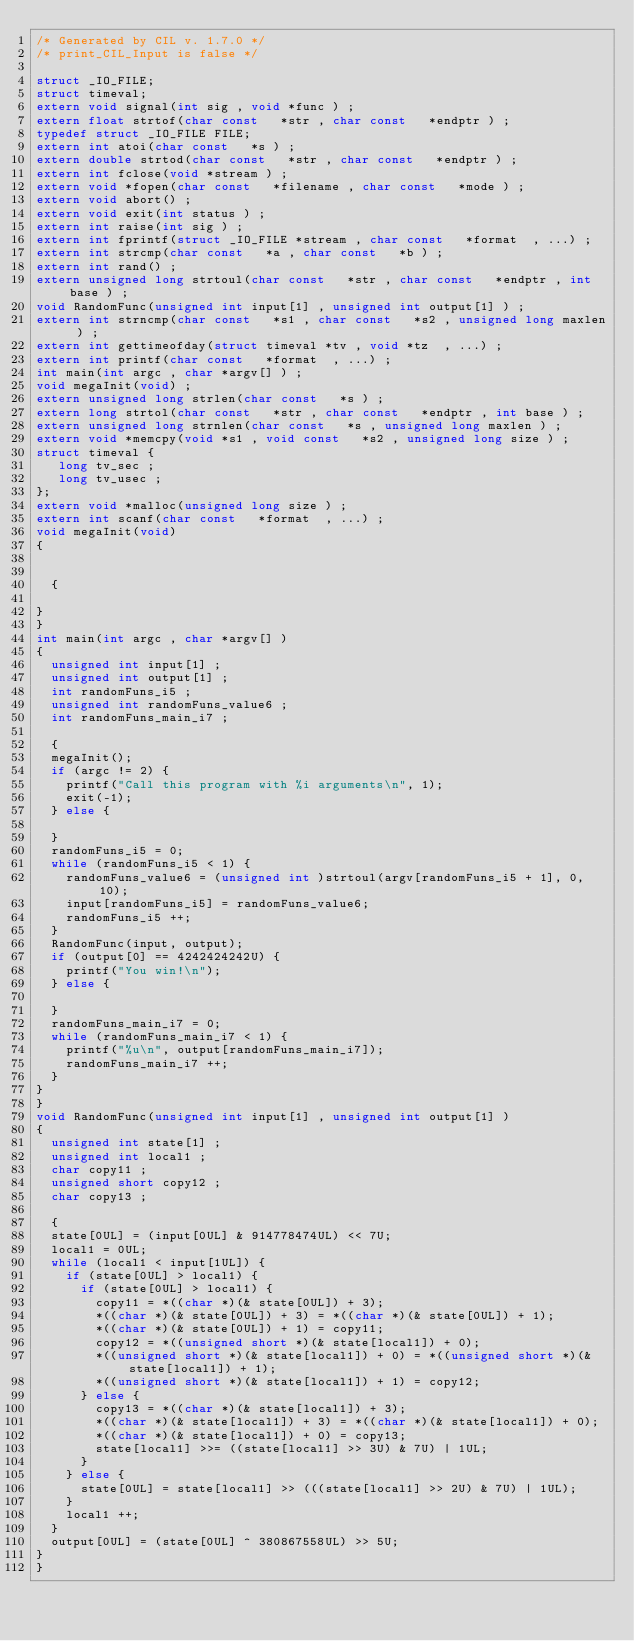<code> <loc_0><loc_0><loc_500><loc_500><_C_>/* Generated by CIL v. 1.7.0 */
/* print_CIL_Input is false */

struct _IO_FILE;
struct timeval;
extern void signal(int sig , void *func ) ;
extern float strtof(char const   *str , char const   *endptr ) ;
typedef struct _IO_FILE FILE;
extern int atoi(char const   *s ) ;
extern double strtod(char const   *str , char const   *endptr ) ;
extern int fclose(void *stream ) ;
extern void *fopen(char const   *filename , char const   *mode ) ;
extern void abort() ;
extern void exit(int status ) ;
extern int raise(int sig ) ;
extern int fprintf(struct _IO_FILE *stream , char const   *format  , ...) ;
extern int strcmp(char const   *a , char const   *b ) ;
extern int rand() ;
extern unsigned long strtoul(char const   *str , char const   *endptr , int base ) ;
void RandomFunc(unsigned int input[1] , unsigned int output[1] ) ;
extern int strncmp(char const   *s1 , char const   *s2 , unsigned long maxlen ) ;
extern int gettimeofday(struct timeval *tv , void *tz  , ...) ;
extern int printf(char const   *format  , ...) ;
int main(int argc , char *argv[] ) ;
void megaInit(void) ;
extern unsigned long strlen(char const   *s ) ;
extern long strtol(char const   *str , char const   *endptr , int base ) ;
extern unsigned long strnlen(char const   *s , unsigned long maxlen ) ;
extern void *memcpy(void *s1 , void const   *s2 , unsigned long size ) ;
struct timeval {
   long tv_sec ;
   long tv_usec ;
};
extern void *malloc(unsigned long size ) ;
extern int scanf(char const   *format  , ...) ;
void megaInit(void) 
{ 


  {

}
}
int main(int argc , char *argv[] ) 
{ 
  unsigned int input[1] ;
  unsigned int output[1] ;
  int randomFuns_i5 ;
  unsigned int randomFuns_value6 ;
  int randomFuns_main_i7 ;

  {
  megaInit();
  if (argc != 2) {
    printf("Call this program with %i arguments\n", 1);
    exit(-1);
  } else {

  }
  randomFuns_i5 = 0;
  while (randomFuns_i5 < 1) {
    randomFuns_value6 = (unsigned int )strtoul(argv[randomFuns_i5 + 1], 0, 10);
    input[randomFuns_i5] = randomFuns_value6;
    randomFuns_i5 ++;
  }
  RandomFunc(input, output);
  if (output[0] == 4242424242U) {
    printf("You win!\n");
  } else {

  }
  randomFuns_main_i7 = 0;
  while (randomFuns_main_i7 < 1) {
    printf("%u\n", output[randomFuns_main_i7]);
    randomFuns_main_i7 ++;
  }
}
}
void RandomFunc(unsigned int input[1] , unsigned int output[1] ) 
{ 
  unsigned int state[1] ;
  unsigned int local1 ;
  char copy11 ;
  unsigned short copy12 ;
  char copy13 ;

  {
  state[0UL] = (input[0UL] & 914778474UL) << 7U;
  local1 = 0UL;
  while (local1 < input[1UL]) {
    if (state[0UL] > local1) {
      if (state[0UL] > local1) {
        copy11 = *((char *)(& state[0UL]) + 3);
        *((char *)(& state[0UL]) + 3) = *((char *)(& state[0UL]) + 1);
        *((char *)(& state[0UL]) + 1) = copy11;
        copy12 = *((unsigned short *)(& state[local1]) + 0);
        *((unsigned short *)(& state[local1]) + 0) = *((unsigned short *)(& state[local1]) + 1);
        *((unsigned short *)(& state[local1]) + 1) = copy12;
      } else {
        copy13 = *((char *)(& state[local1]) + 3);
        *((char *)(& state[local1]) + 3) = *((char *)(& state[local1]) + 0);
        *((char *)(& state[local1]) + 0) = copy13;
        state[local1] >>= ((state[local1] >> 3U) & 7U) | 1UL;
      }
    } else {
      state[0UL] = state[local1] >> (((state[local1] >> 2U) & 7U) | 1UL);
    }
    local1 ++;
  }
  output[0UL] = (state[0UL] ^ 380867558UL) >> 5U;
}
}
</code> 